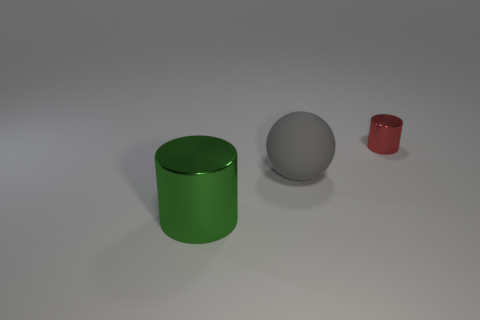There is a big thing that is on the right side of the large green object; is its shape the same as the shiny thing that is in front of the sphere?
Your response must be concise. No. How many things are either cylinders in front of the tiny metallic cylinder or metallic objects that are in front of the small metallic thing?
Make the answer very short. 1. How many other things are the same material as the red cylinder?
Provide a succinct answer. 1. Are the gray sphere left of the small cylinder and the small cylinder made of the same material?
Make the answer very short. No. Is the number of big green objects right of the gray ball greater than the number of tiny metallic objects in front of the red metallic cylinder?
Provide a succinct answer. No. How many objects are either cylinders that are in front of the small cylinder or gray matte spheres?
Ensure brevity in your answer.  2. What is the shape of the other big object that is the same material as the red thing?
Provide a short and direct response. Cylinder. Is there any other thing that has the same shape as the green object?
Make the answer very short. Yes. There is a object that is in front of the tiny thing and right of the green shiny cylinder; what is its color?
Ensure brevity in your answer.  Gray. How many cylinders are red metal objects or gray objects?
Offer a terse response. 1. 